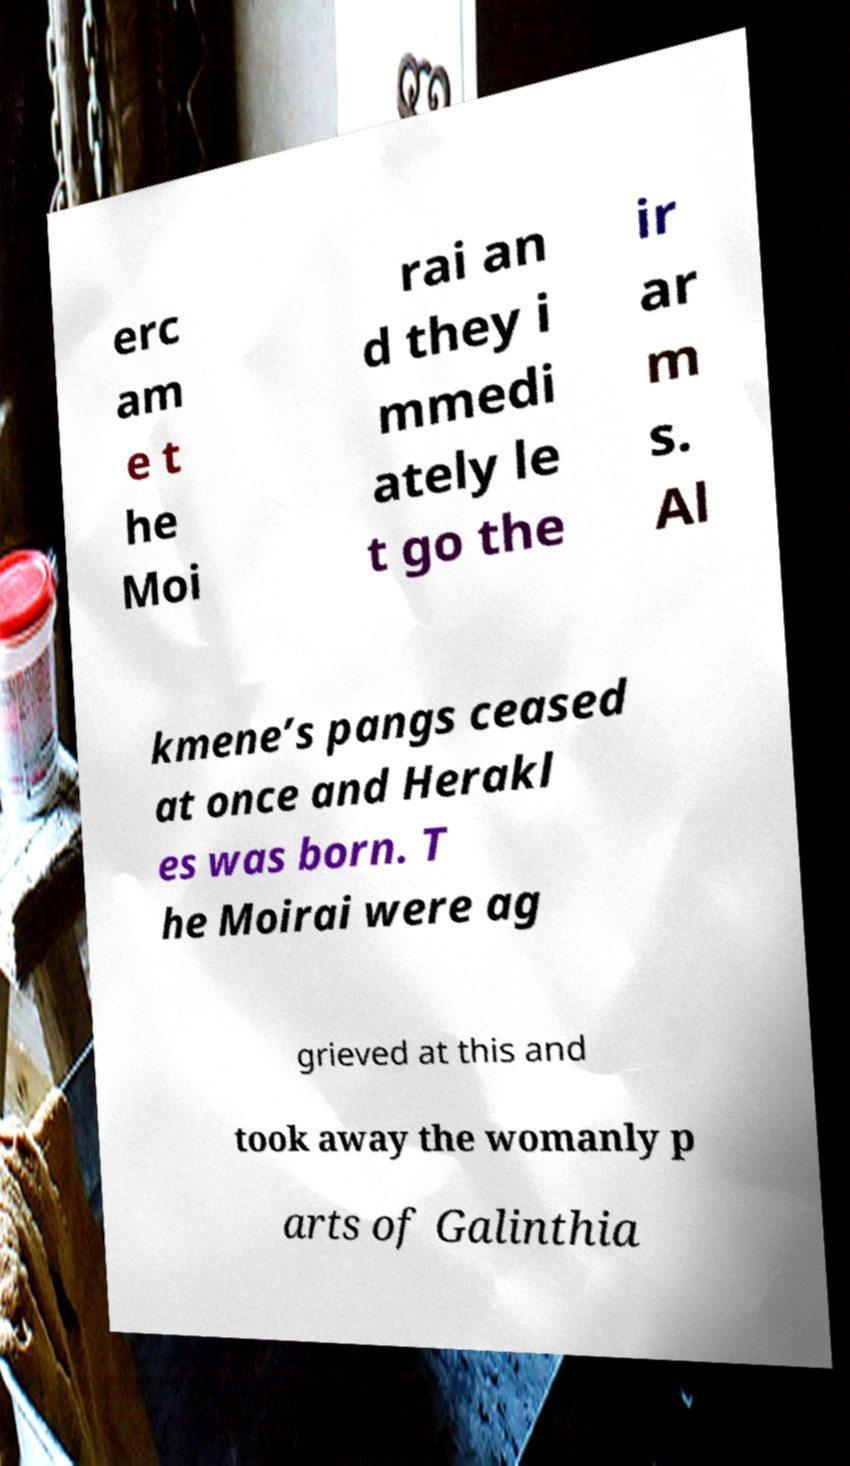Can you read and provide the text displayed in the image?This photo seems to have some interesting text. Can you extract and type it out for me? erc am e t he Moi rai an d they i mmedi ately le t go the ir ar m s. Al kmene’s pangs ceased at once and Herakl es was born. T he Moirai were ag grieved at this and took away the womanly p arts of Galinthia 